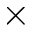<formula> <loc_0><loc_0><loc_500><loc_500>\times</formula> 